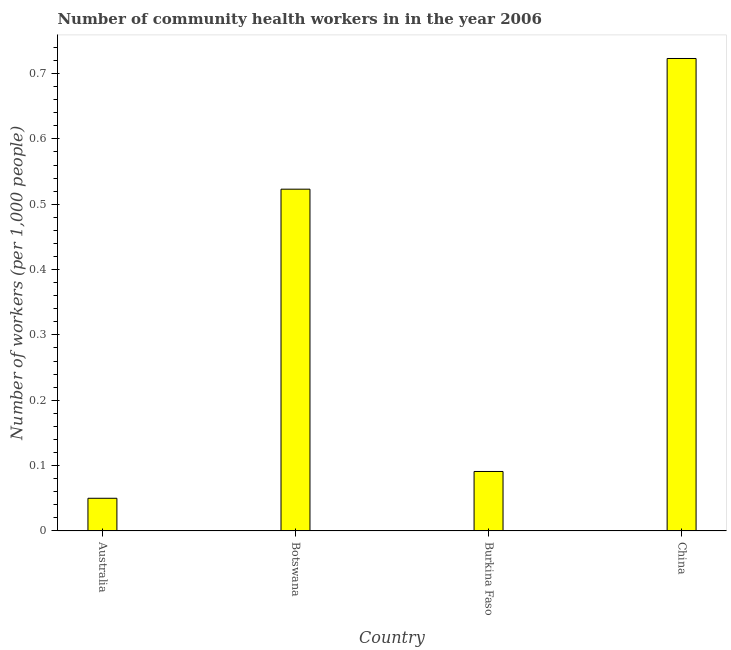Does the graph contain any zero values?
Keep it short and to the point. No. What is the title of the graph?
Keep it short and to the point. Number of community health workers in in the year 2006. What is the label or title of the Y-axis?
Your response must be concise. Number of workers (per 1,0 people). What is the number of community health workers in Botswana?
Offer a terse response. 0.52. Across all countries, what is the maximum number of community health workers?
Keep it short and to the point. 0.72. In which country was the number of community health workers maximum?
Your answer should be compact. China. In which country was the number of community health workers minimum?
Make the answer very short. Australia. What is the sum of the number of community health workers?
Give a very brief answer. 1.39. What is the difference between the number of community health workers in Botswana and Burkina Faso?
Give a very brief answer. 0.43. What is the average number of community health workers per country?
Offer a very short reply. 0.35. What is the median number of community health workers?
Give a very brief answer. 0.31. In how many countries, is the number of community health workers greater than 0.7 ?
Provide a succinct answer. 1. What is the ratio of the number of community health workers in Burkina Faso to that in China?
Your answer should be very brief. 0.13. Is the number of community health workers in Botswana less than that in China?
Provide a succinct answer. Yes. Is the difference between the number of community health workers in Australia and China greater than the difference between any two countries?
Your answer should be compact. Yes. What is the difference between the highest and the lowest number of community health workers?
Provide a short and direct response. 0.67. In how many countries, is the number of community health workers greater than the average number of community health workers taken over all countries?
Give a very brief answer. 2. How many bars are there?
Your answer should be very brief. 4. Are all the bars in the graph horizontal?
Provide a succinct answer. No. Are the values on the major ticks of Y-axis written in scientific E-notation?
Keep it short and to the point. No. What is the Number of workers (per 1,000 people) in Australia?
Give a very brief answer. 0.05. What is the Number of workers (per 1,000 people) in Botswana?
Provide a succinct answer. 0.52. What is the Number of workers (per 1,000 people) of Burkina Faso?
Your answer should be very brief. 0.09. What is the Number of workers (per 1,000 people) of China?
Your response must be concise. 0.72. What is the difference between the Number of workers (per 1,000 people) in Australia and Botswana?
Make the answer very short. -0.47. What is the difference between the Number of workers (per 1,000 people) in Australia and Burkina Faso?
Offer a terse response. -0.04. What is the difference between the Number of workers (per 1,000 people) in Australia and China?
Offer a terse response. -0.67. What is the difference between the Number of workers (per 1,000 people) in Botswana and Burkina Faso?
Your answer should be very brief. 0.43. What is the difference between the Number of workers (per 1,000 people) in Burkina Faso and China?
Offer a very short reply. -0.63. What is the ratio of the Number of workers (per 1,000 people) in Australia to that in Botswana?
Ensure brevity in your answer.  0.1. What is the ratio of the Number of workers (per 1,000 people) in Australia to that in Burkina Faso?
Offer a very short reply. 0.55. What is the ratio of the Number of workers (per 1,000 people) in Australia to that in China?
Your answer should be very brief. 0.07. What is the ratio of the Number of workers (per 1,000 people) in Botswana to that in Burkina Faso?
Offer a terse response. 5.75. What is the ratio of the Number of workers (per 1,000 people) in Botswana to that in China?
Offer a terse response. 0.72. What is the ratio of the Number of workers (per 1,000 people) in Burkina Faso to that in China?
Make the answer very short. 0.13. 